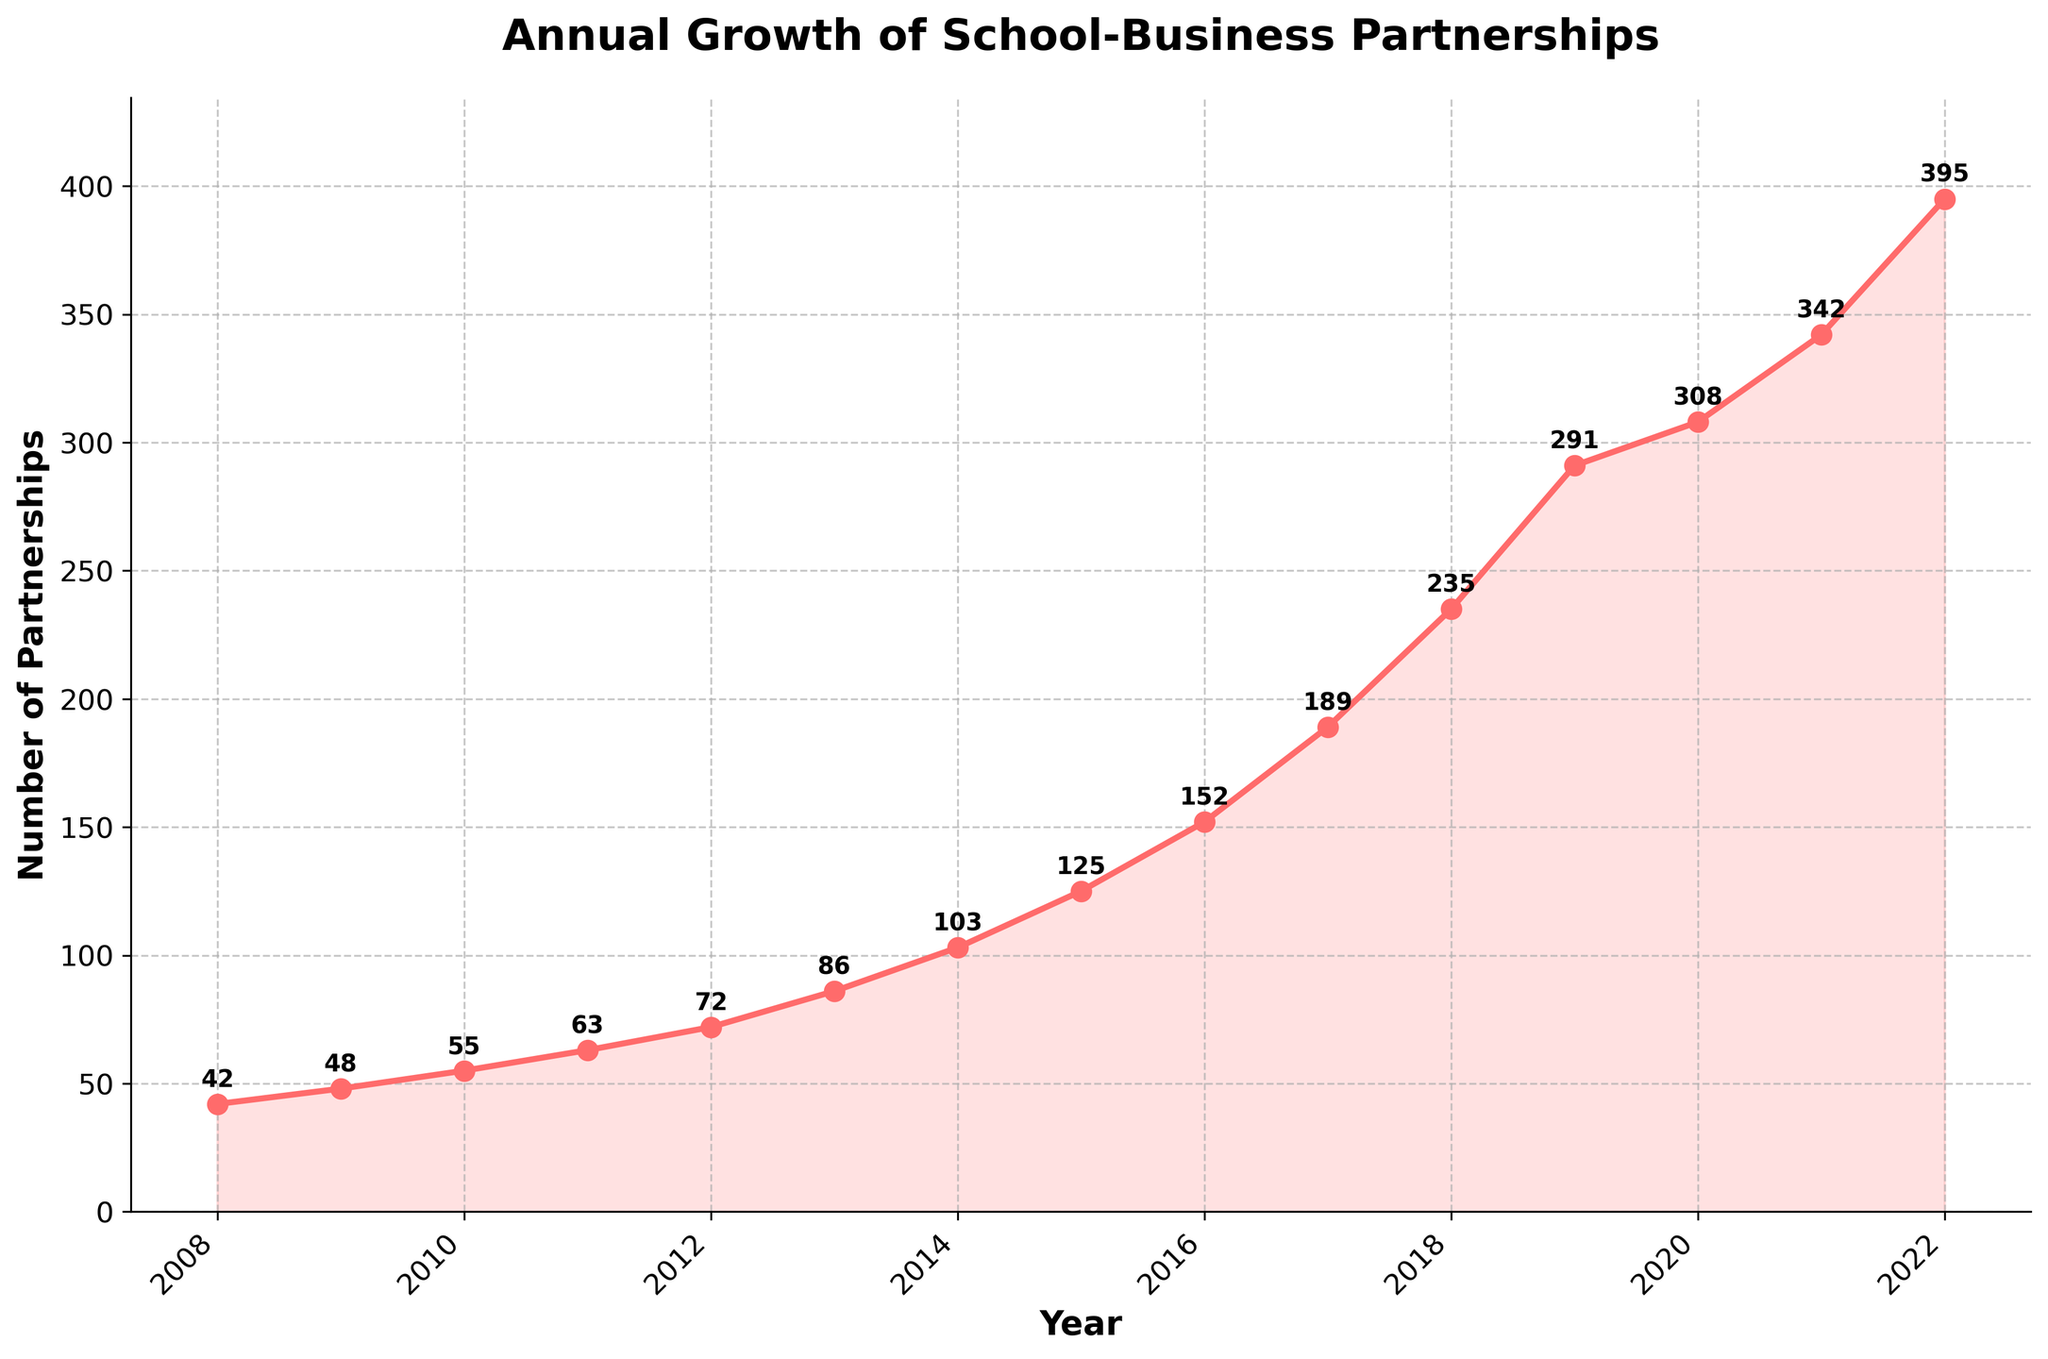How many partnerships existed in 2008? Look at the graph and locate the data point for the year 2008. The y-axis value corresponding to this year is 42.
Answer: 42 Between which consecutive years did the number of partnerships increase the most? Observe the steepness of the lines between each pair of consecutive years. The steepest segment is between 2018 and 2019, where the number of partnerships increased significantly.
Answer: 2018-2019 What is the average number of partnerships from 2010 to 2015 inclusive? Add the number of partnerships from 2010 (55), 2011 (63), 2012 (72), 2013 (86), 2014 (103), and 2015 (125), and then divide by the number of years (6). The calculation is (55 + 63 + 72 + 86 + 103 + 125)/6 = 84
Answer: 84 Which year had the smallest number of partnerships, and how many were there? Look for the lowest point on the graph, which is in the year 2008 with 42 partnerships.
Answer: 2008, 42 What was the percentage increase in partnerships from 2019 to 2020? The number of partnerships in 2019 was 291 and in 2020 it was 308. The percentage increase is calculated by ((308 - 291) / 291) * 100 = 5.84%.
Answer: 5.84% How many partnerships were there in 2015, and how does this compare to the number in 2021? The graph shows there were 125 partnerships in 2015 and 342 in 2021. The difference is 342 - 125 = 217.
Answer: 217 more in 2021 During which year did the number of partnerships reach over 100 for the first time? Follow the line and see when it first crosses the 100 mark. That happens in the year 2014 with 103 partnerships.
Answer: 2014 What is the total growth in partnerships from 2008 to 2022? Subtract the number of partnerships in 2008 (42) from the number in 2022 (395). The total growth is 395 - 42 = 353.
Answer: 353 Is there a year where the annual number of partnerships decreased compared to the previous year? Check the slope between each of the consecutive years. There is no decrease in any year, as the line consistently goes up.
Answer: No By how much did the number of partnerships grow on average per year between 2008 and 2022? Subtract the number of partnerships in 2008 from 2022, then divide by the number of years (2022 - 2008). The calculation is (395 - 42) / (2022 - 2008) = 353 / 14 = 25.21.
Answer: 25.21 